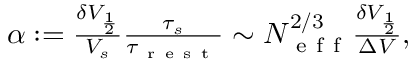<formula> <loc_0><loc_0><loc_500><loc_500>\begin{array} { r } { \alpha \colon = \frac { \delta V _ { \frac { 1 } { 2 } } } { V _ { s } } \frac { \tau _ { s } } { \tau _ { r e s t } } \sim N _ { e f f } ^ { 2 / 3 } \frac { \delta V _ { \frac { 1 } { 2 } } } { \Delta V } , } \end{array}</formula> 